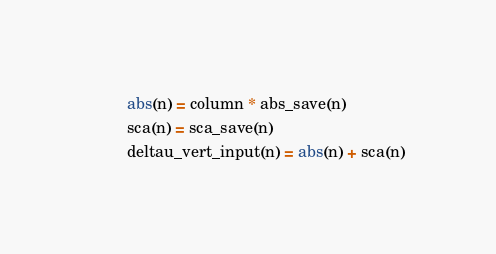<code> <loc_0><loc_0><loc_500><loc_500><_FORTRAN_>        abs(n) = column * abs_save(n)
        sca(n) = sca_save(n)
        deltau_vert_input(n) = abs(n) + sca(n)</code> 